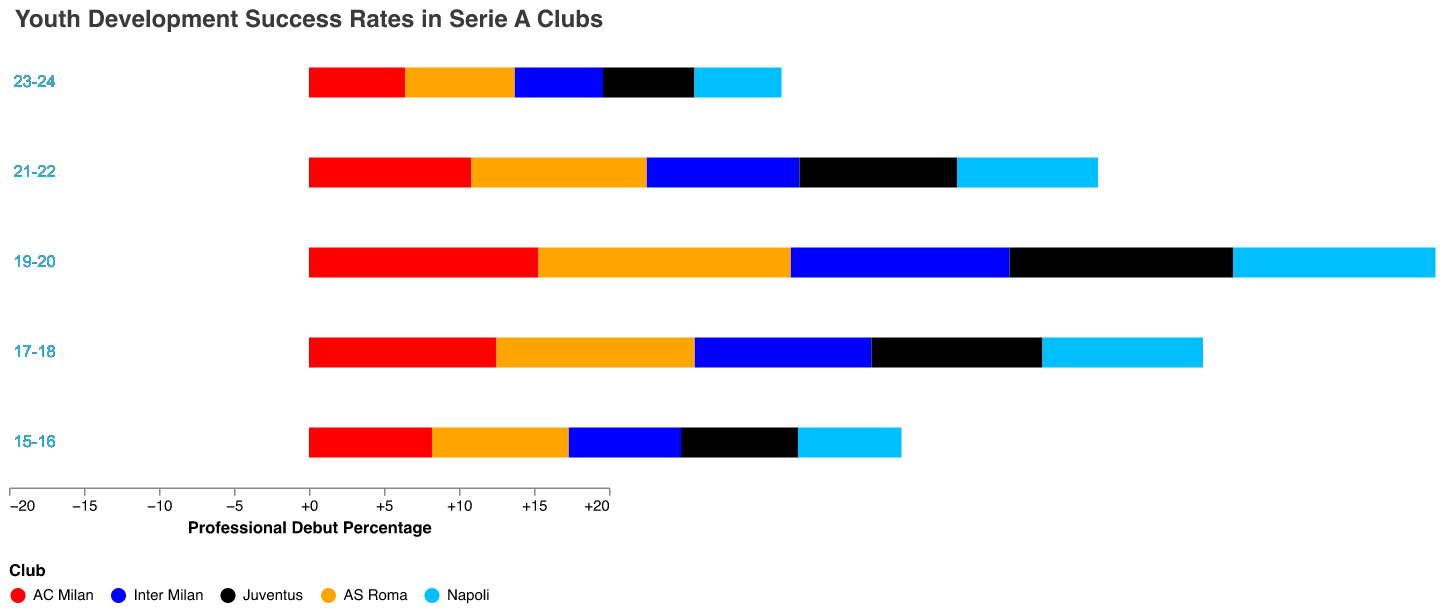What's the title of the figure? The title is located at the top of the figure and it reads "Youth Development Success Rates in Serie A Clubs".
Answer: Youth Development Success Rates in Serie A Clubs What is the professional debut percentage for AC Milan in the '15-16' age group? Look at the bar for AC Milan in the '15-16' age group, it’s around -8.2%.
Answer: -8.2% Which club shows the highest professional debut percentage for the '17-18' age group? Compare the bars for all clubs in the '17-18' age group, AS Roma has the highest value of around 13.2%.
Answer: AS Roma How does Inter Milan’s success rate in the '19-20' age group compare to that of Napoli? Compare the heights of the bars for Inter Milan and Napoli in the '19-20' age group. Inter Milan has a higher success rate of 14.6% compared to Napoli’s -13.5%.
Answer: Inter Milan is higher What’s the average professional debut percentage for Juventus across all age groups? Sum the values for Juventus: (-7.8 - 11.4 - 14.9 - 10.5 - 6.1) and divide by the number of age groups, which is 5.
Answer: -10.14% Which club has the lowest overall success rate when considering the '23-24' age group? Find the minimum value for the '23-24' age group, which is for Napoli at -5.8%.
Answer: Napoli For AS Roma, what is the difference in the professional debut percentage between the '19-20' and '21-22' age groups? Subtract the '21-22' value from the '19-20' value for AS Roma: 16.8% - 11.7%.
Answer: 5.1% Which age group demonstrates the biggest range in professional debut percentages among all clubs? Identify the age group with the largest difference between the highest and lowest values. The '19-20' age group shows the most significant range from -15.3% (AC Milan) to 16.8% (AS Roma), a difference of 32.1%.
Answer: '19-20' Between the '17-18' and '23-24' age groups, which group had a higher professional debut percentage for Inter Milan? Compare the values for Inter Milan: '17-18' has 11.8% and '23-24' has 5.9%.
Answer: '17-18' On the whole, which club shows more positive professional debut percentages across age groups: Inter Milan or AS Roma? Look at the bars for Inter Milan and AS Roma across all age groups, AS Roma consistently has positive percentages across all displayed age groups.
Answer: AS Roma 